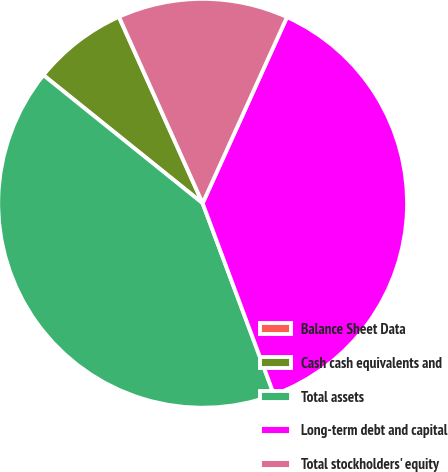Convert chart to OTSL. <chart><loc_0><loc_0><loc_500><loc_500><pie_chart><fcel>Balance Sheet Data<fcel>Cash cash equivalents and<fcel>Total assets<fcel>Long-term debt and capital<fcel>Total stockholders' equity<nl><fcel>0.01%<fcel>7.49%<fcel>41.46%<fcel>37.55%<fcel>13.48%<nl></chart> 